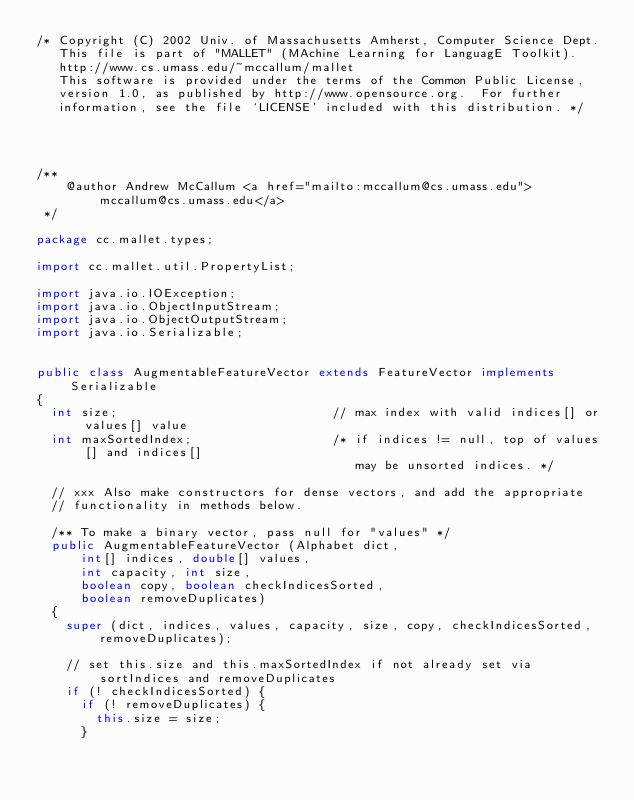<code> <loc_0><loc_0><loc_500><loc_500><_Java_>/* Copyright (C) 2002 Univ. of Massachusetts Amherst, Computer Science Dept.
   This file is part of "MALLET" (MAchine Learning for LanguagE Toolkit).
   http://www.cs.umass.edu/~mccallum/mallet
   This software is provided under the terms of the Common Public License,
   version 1.0, as published by http://www.opensource.org.  For further
   information, see the file `LICENSE' included with this distribution. */




/** 
		@author Andrew McCallum <a href="mailto:mccallum@cs.umass.edu">mccallum@cs.umass.edu</a>
 */

package cc.mallet.types;

import cc.mallet.util.PropertyList;

import java.io.IOException;
import java.io.ObjectInputStream;
import java.io.ObjectOutputStream;
import java.io.Serializable;


public class AugmentableFeatureVector extends FeatureVector implements Serializable
{
	int size;															// max index with valid indices[] or values[] value 
	int maxSortedIndex;										/* if indices != null, top of values[] and indices[]
																					 may be unsorted indices. */

	// xxx Also make constructors for dense vectors, and add the appropriate
	// functionality in methods below.

	/** To make a binary vector, pass null for "values" */
	public AugmentableFeatureVector (Alphabet dict,
			int[] indices, double[] values, 
			int capacity, int size,
			boolean copy, boolean checkIndicesSorted,
			boolean removeDuplicates)
	{
		super (dict, indices, values, capacity, size, copy, checkIndicesSorted, removeDuplicates);

		// set this.size and this.maxSortedIndex if not already set via sortIndices and removeDuplicates 
		if (! checkIndicesSorted) {
			if (! removeDuplicates) {
				this.size = size;
			}</code> 